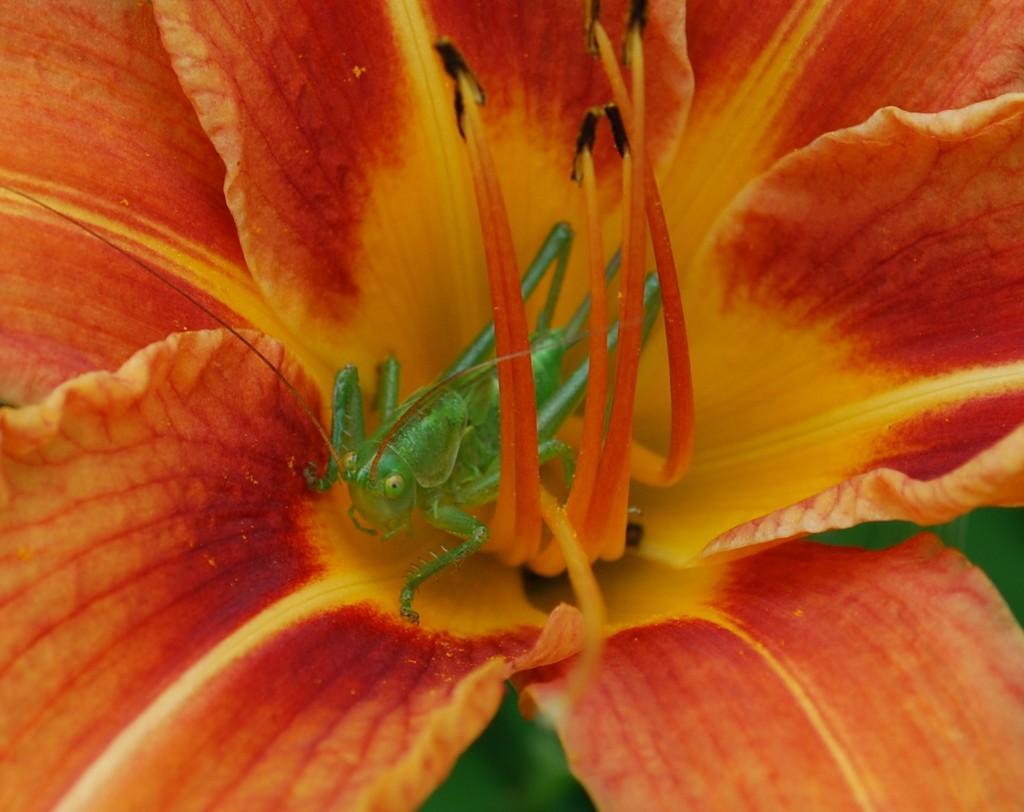Can you describe this image briefly? In this image, It looks like a grasshopper, which is on the floor. This flower looks orange and yellow in color. The background looks green in color. 